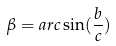Convert formula to latex. <formula><loc_0><loc_0><loc_500><loc_500>\beta = a r c \sin ( \frac { b } { c } )</formula> 